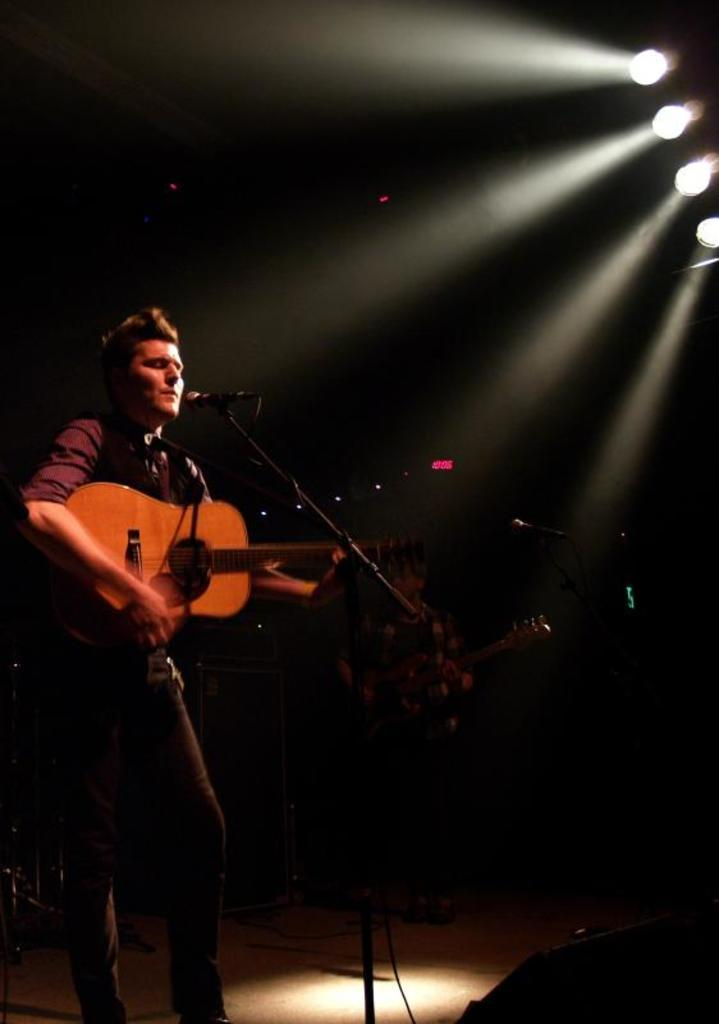What is the man in the image doing? The man is playing the guitar in the image. What object is the man holding while playing the guitar? The man is holding a guitar in the image. Where is the man positioned in relation to the microphone? The man is in front of a microphone in the image. What is the other person in the image doing? The other person is also playing a guitar in the image. What can be seen in the background of the image? There are lights visible in the image. What type of zipper can be seen on the man's guitar in the image? There is no zipper present on the man's guitar in the image. What kind of party is being held in the image? There is no party depicted in the image; it shows two people playing guitars in front of a microphone. 